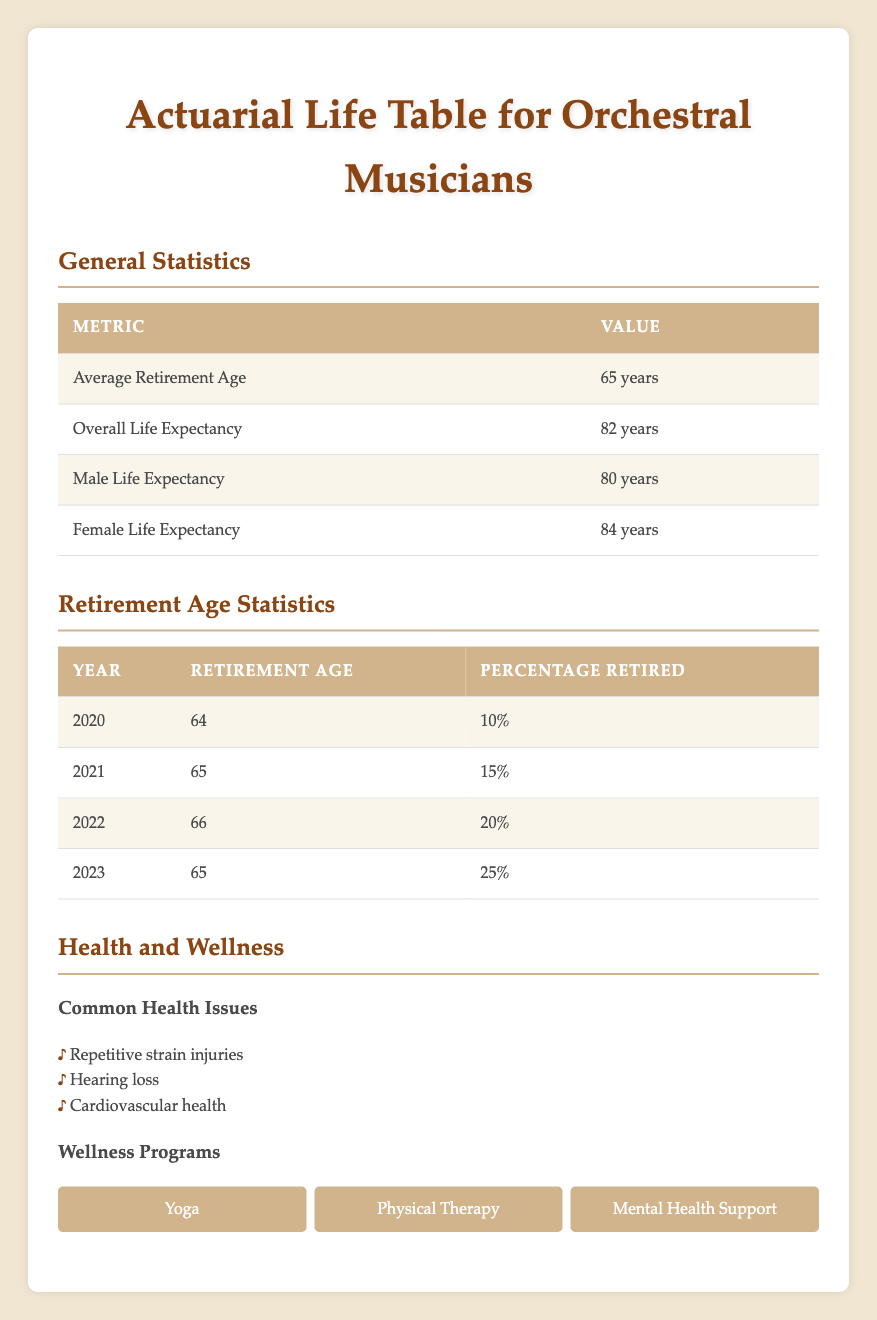What is the average retirement age for orchestral musicians? The average retirement age for orchestral musicians is provided in the general statistics section of the table, which clearly states that it is 65 years.
Answer: 65 years In which year did the percentage of retired orchestral musicians reach 20%? The retirement age statistics table shows the years along with the corresponding percentages retired. It indicates that in the year 2022, the percentage retired was 20%.
Answer: 2022 What was the retirement age in 2021? Looking at the retirement age statistics for the year 2021, it shows that the retirement age was 65 years.
Answer: 65 years Is it true that the life expectancy for female orchestral musicians is greater than that for male musicians? The data section specifies life expectancy by gender, stating that the life expectancy for females is 84 years and for males is 80 years. Thus, it confirms that females have a higher life expectancy than males.
Answer: Yes Calculate the average retirement age over the four years (2020-2023) provided in the data. To find the average retirement age from 2020 to 2023, I sum the retirement ages for each year: 64 (2020) + 65 (2021) + 66 (2022) + 65 (2023) = 260. Dividing by the number of years (4) gives an average retirement age of 260/4 = 65 years.
Answer: 65 years What percentage of orchestral musicians were retired in 2023? The retirement age statistics table indicates that in 2023, the percentage of retired orchestral musicians was 25%.
Answer: 25% Which health issue is most common among orchestral musicians according to the data? The health and wellness section lists common health issues faced by orchestral musicians. It includes three issues: repetitive strain injuries, hearing loss, and cardiovascular health, but does not rank them. Therefore, we can only identify these three as common but not determine which is the most common from the available data.
Answer: Cannot be determined If the trend continues, what percentage of orchestral musicians might be retired in 2024 based on previous data? The percentages retired from 2020 to 2023 are increasing. 10% (2020) to 25% (2023) shows an increase of 15% over 4 years. This gives an average increase of approximately 3.75% per year. If this trend holds, we estimate that the percentage in 2024 could be around 25% + 3.75% = 28.75%.
Answer: Approximately 29% 